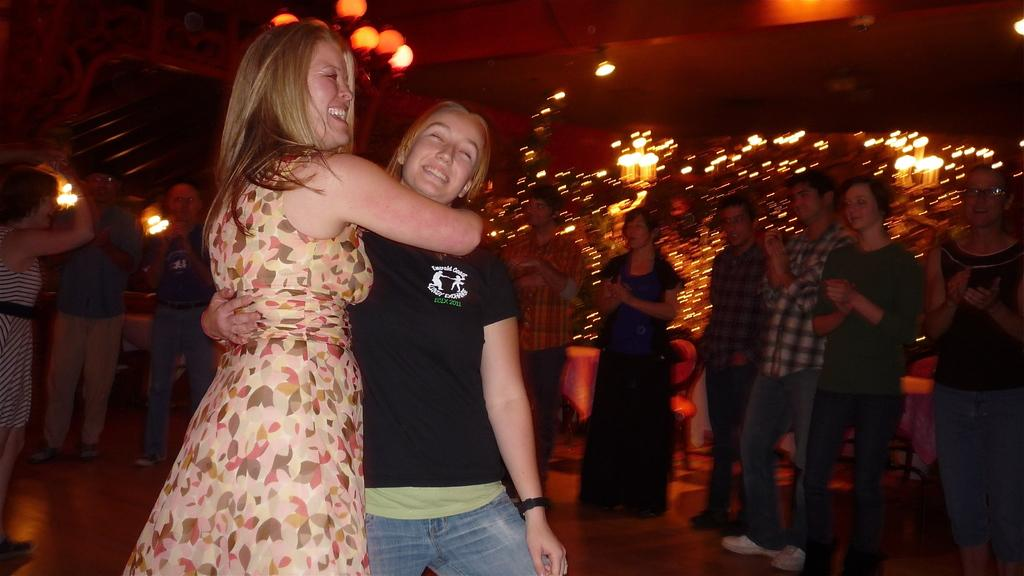What are the people in the image doing? Some people are standing and holding each other in the image. What can be seen on the ceiling in the image? There are lights on the ceiling in the image. What type of furniture is present in the image? There are chairs and tables in the image. What type of basket is hanging from the ceiling in the image? There is no basket hanging from the ceiling in the image. How does the wire connect to the chairs in the image? There is no wire connecting to the chairs in the image. 